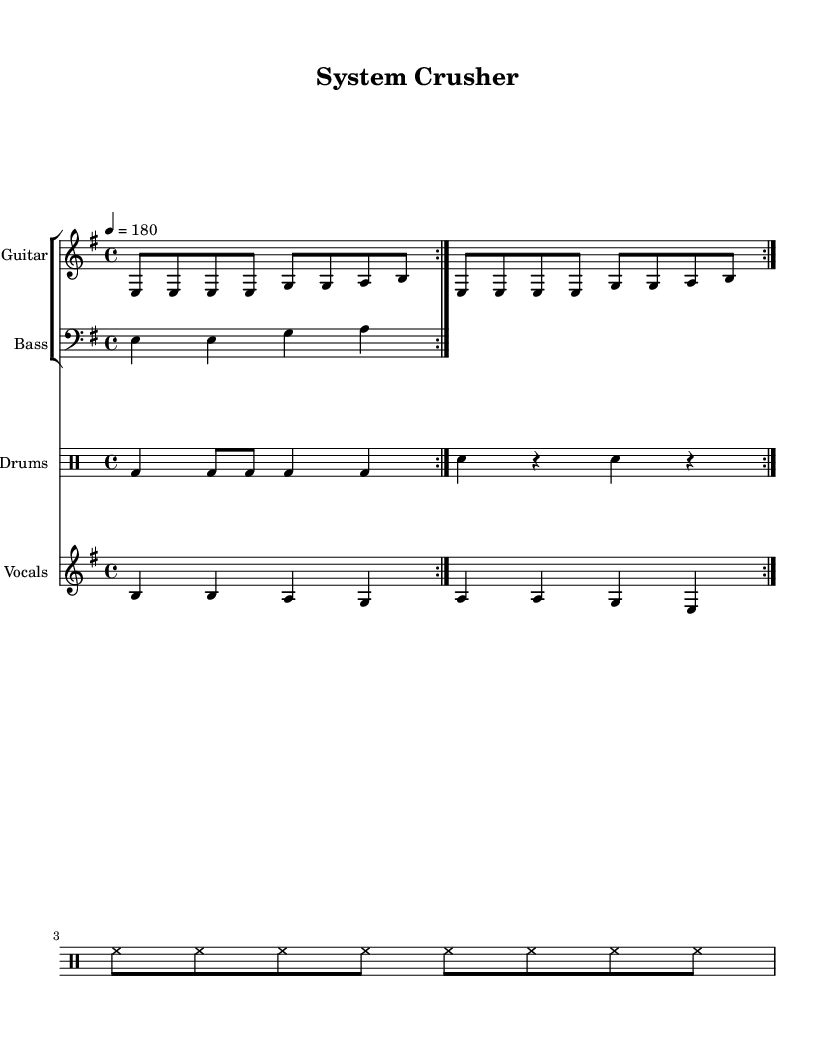What is the key signature of this music? The key signature is E minor, which has one sharp (F#). Since the music starts with an E note and maintains the tonality throughout, we identify it as E minor.
Answer: E minor What is the time signature of this music? The time signature is 4/4, as indicated in the music sheet, where there are four beats per measure. This is a common time signature in punk music.
Answer: 4/4 What is the tempo marking for this piece? The tempo marking is 180 beats per minute, shown at the beginning of the score, which indicates a fast pace typical of hardcore punk.
Answer: 180 What instruments are used in this piece? The instruments used are Guitar, Bass, Drums, and Vocals. Each is assigned to a separate staff in the score to represent their parts distinctly.
Answer: Guitar, Bass, Drums, and Vocals How many measures are in the vocal section? The vocal section contains four measures, as reflected in the notation where the vocal melody aligns with the lyrics, covering a specific range of bars.
Answer: Four What theme do the lyrics of this song represent? The lyrics represent an anti-establishment theme, as they include phrases about breaking chains and refusing to bow to authority, which is a common sentiment in punk music.
Answer: Anti-establishment What technique is used for the guitar riff? The guitar riff utilizes repeated eighth notes, indicating a driving, aggressive style commonly found in hardcore punk. This repetition is a hallmark of the genre's musical approach.
Answer: Repeated eighth notes 